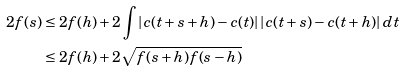<formula> <loc_0><loc_0><loc_500><loc_500>2 f ( s ) & \leq 2 f ( h ) + 2 \int | c ( t + s + h ) - c ( t ) | \, | c ( t + s ) - c ( t + h ) | \, d t \\ & \leq 2 f ( h ) + 2 \sqrt { f ( s + h ) f ( s - h ) }</formula> 